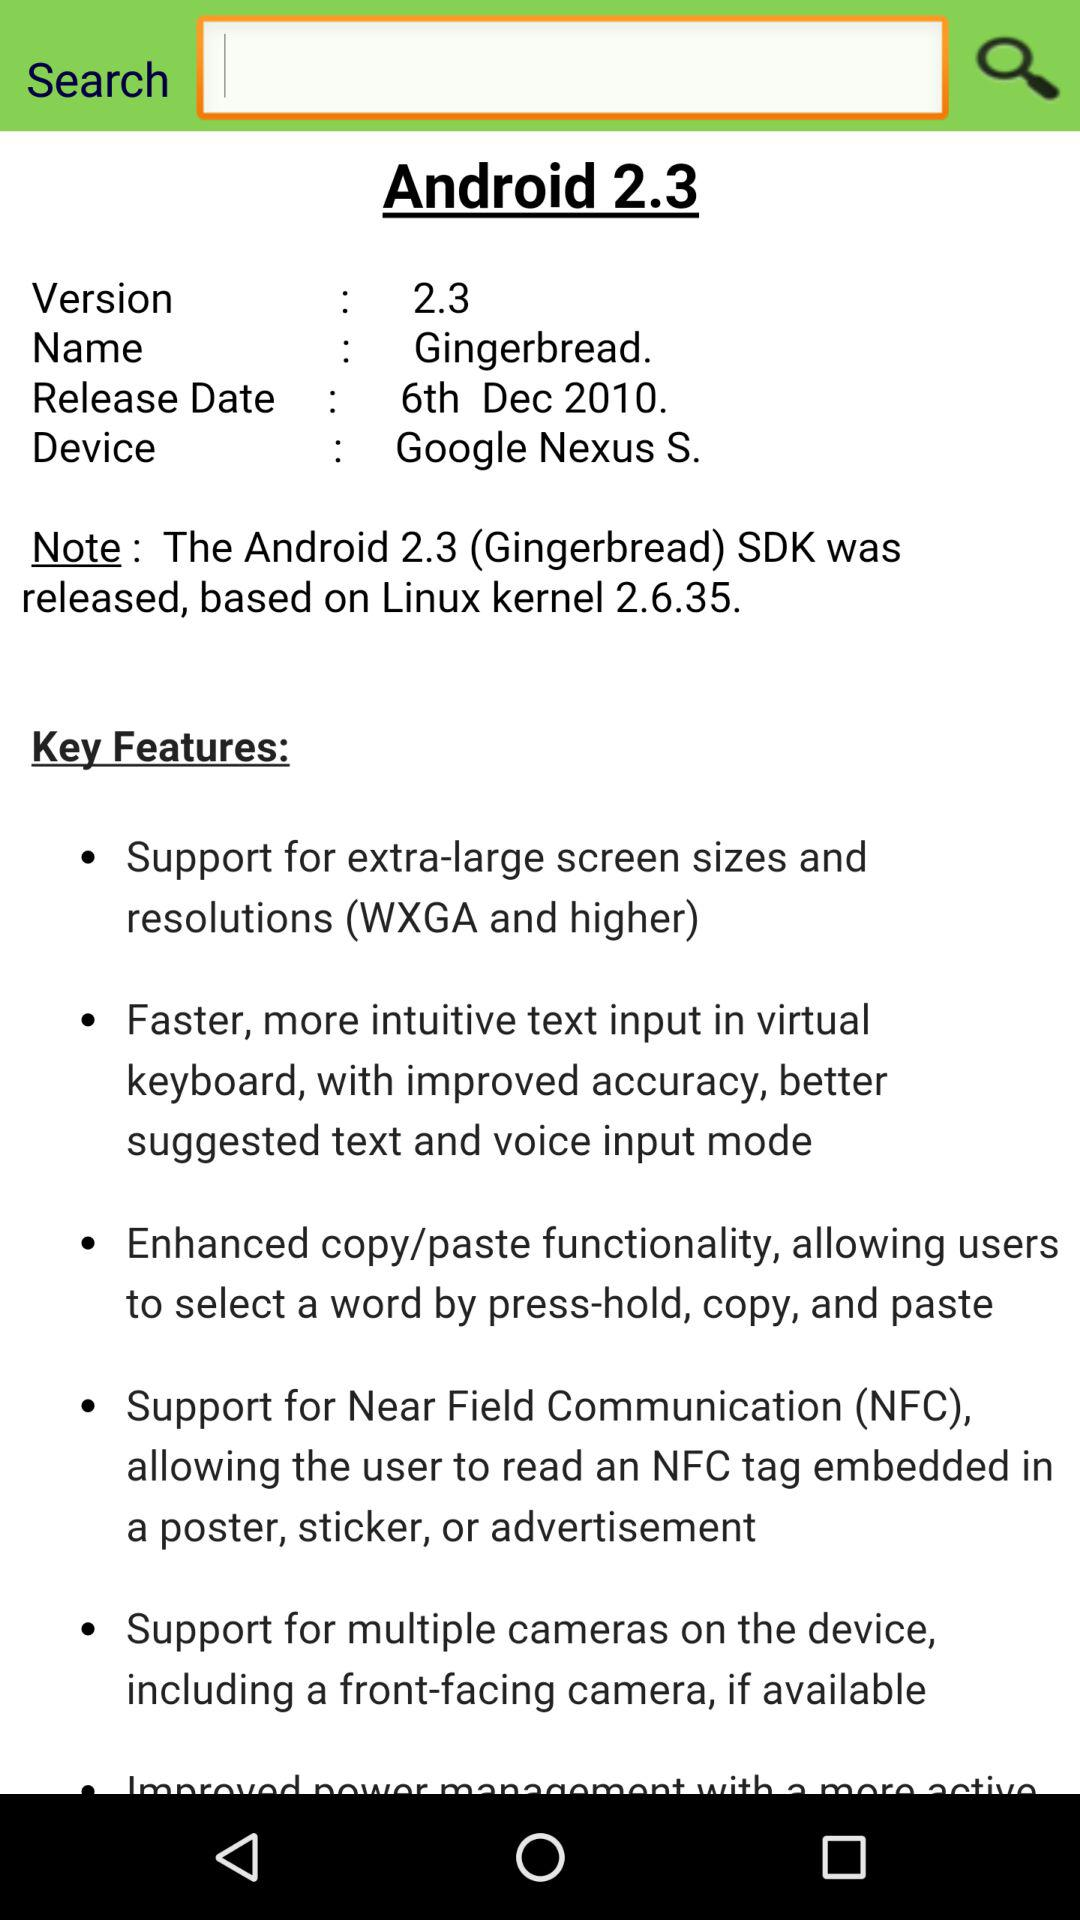On what date was the Android released? The Android was released on December 6, 2010. 